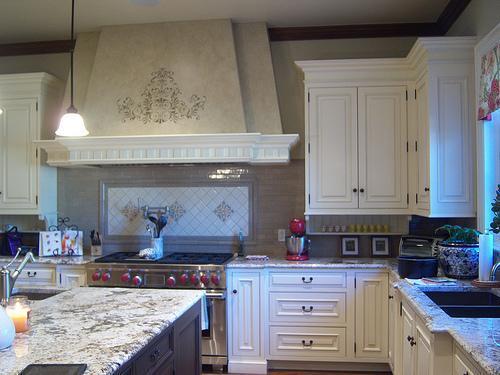How many candles are there?
Give a very brief answer. 1. 